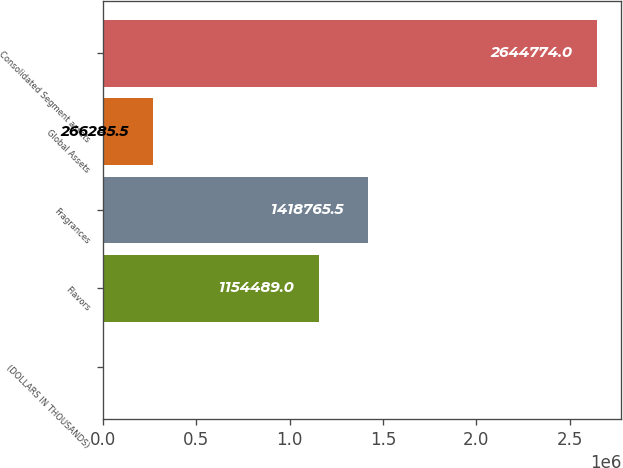<chart> <loc_0><loc_0><loc_500><loc_500><bar_chart><fcel>(DOLLARS IN THOUSANDS)<fcel>Flavors<fcel>Fragrances<fcel>Global Assets<fcel>Consolidated Segment assets<nl><fcel>2009<fcel>1.15449e+06<fcel>1.41877e+06<fcel>266286<fcel>2.64477e+06<nl></chart> 